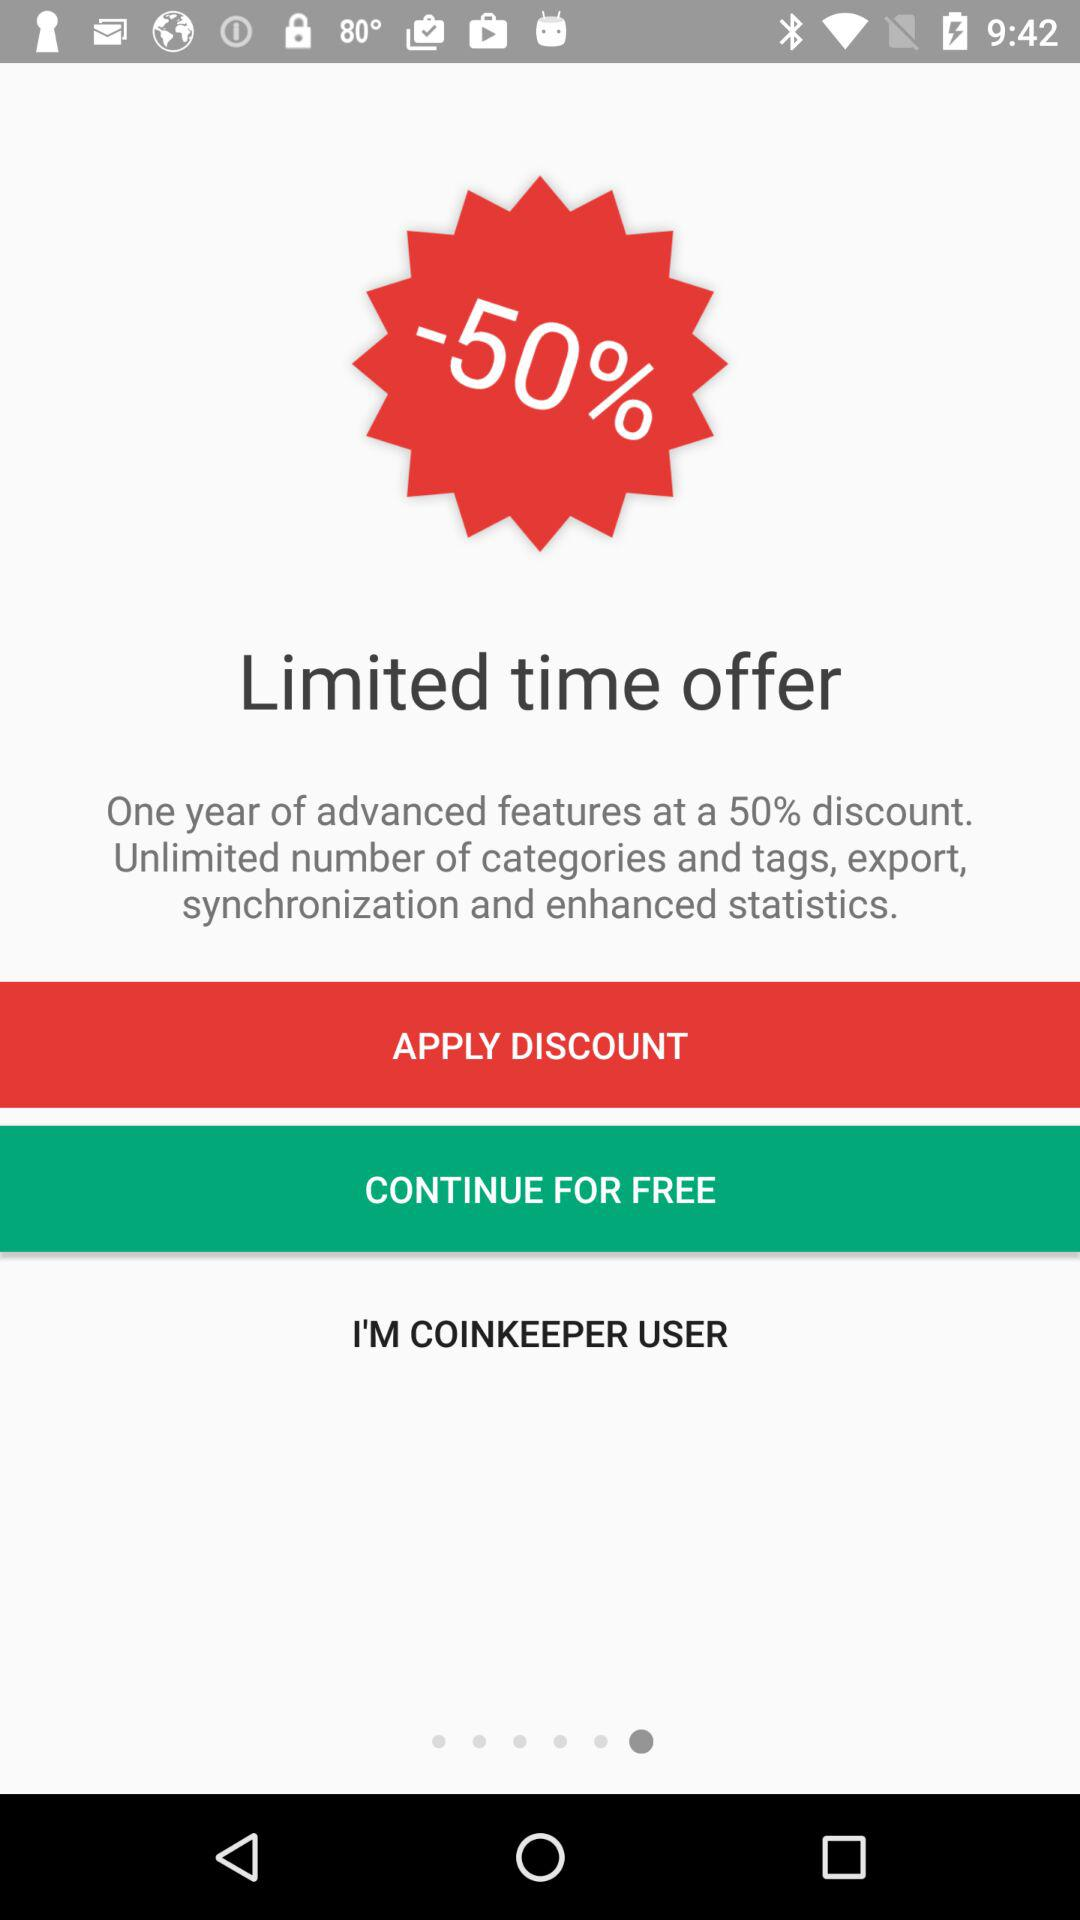How much discount is offered on advanced features?
Answer the question using a single word or phrase. 50% 